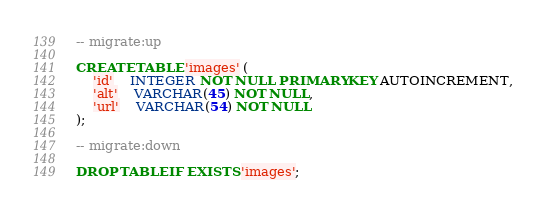<code> <loc_0><loc_0><loc_500><loc_500><_SQL_>-- migrate:up

CREATE TABLE 'images' (
	'id'	INTEGER NOT NULL PRIMARY KEY AUTOINCREMENT,
	'alt'	VARCHAR(45) NOT NULL,
	'url'	VARCHAR(54) NOT NULL
);

-- migrate:down

DROP TABLE IF EXISTS 'images';</code> 